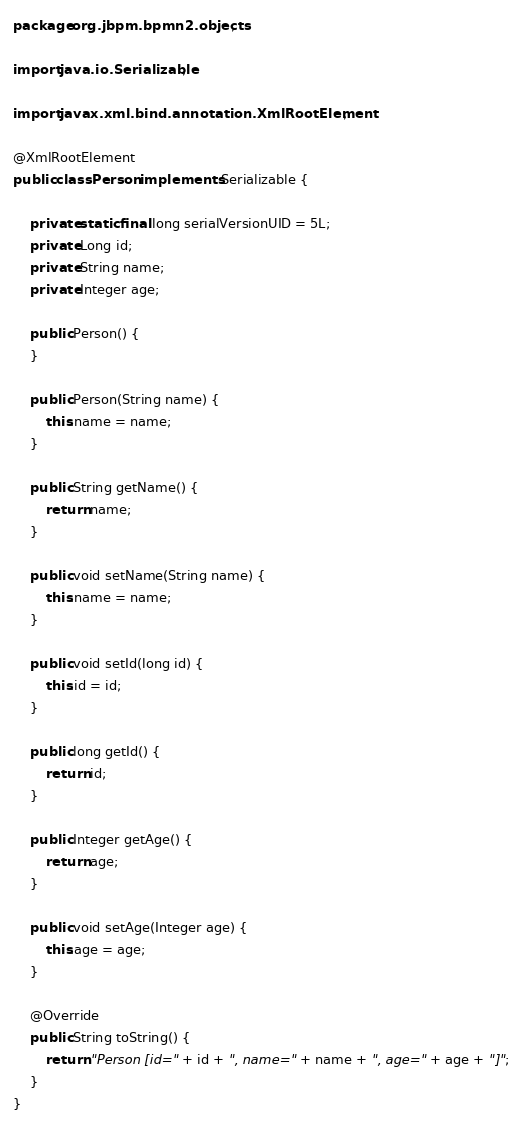Convert code to text. <code><loc_0><loc_0><loc_500><loc_500><_Java_>package org.jbpm.bpmn2.objects;

import java.io.Serializable;

import javax.xml.bind.annotation.XmlRootElement;

@XmlRootElement
public class Person implements Serializable {
    
	private static final long serialVersionUID = 5L;
	private Long id;
	private String name;
	private Integer age;

    public Person() {
    }
    
    public Person(String name) {
        this.name = name;
    }

    public String getName() {
        return name;
    }

    public void setName(String name) {
        this.name = name;
    }

    public void setId(long id) {
        this.id = id;
    }

    public long getId() {
        return id;
    }

    public Integer getAge() {
        return age;
    }

    public void setAge(Integer age) {
        this.age = age;
    }

    @Override
    public String toString() {
        return "Person [id=" + id + ", name=" + name + ", age=" + age + "]";
    }
}
</code> 